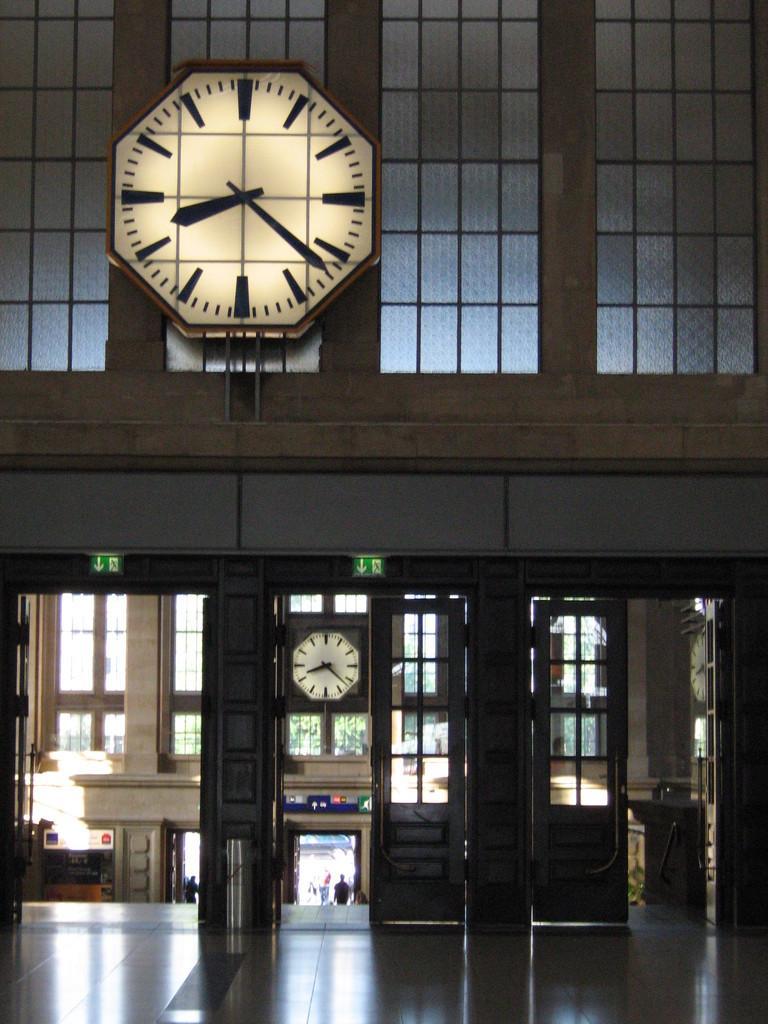Please provide a concise description of this image. Inside a building there is a big clock kept in front of the windows and below that there are doors and there is another clock kept in front of one of the window, behind the doors there is some architecture. 